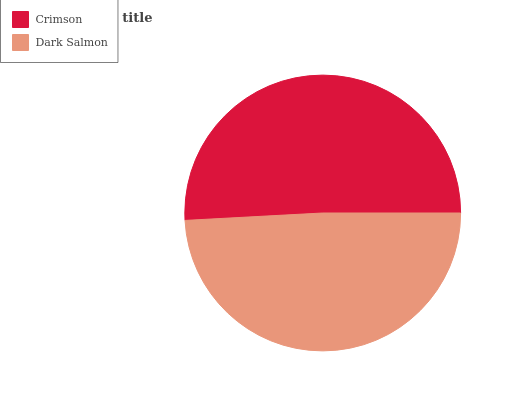Is Dark Salmon the minimum?
Answer yes or no. Yes. Is Crimson the maximum?
Answer yes or no. Yes. Is Dark Salmon the maximum?
Answer yes or no. No. Is Crimson greater than Dark Salmon?
Answer yes or no. Yes. Is Dark Salmon less than Crimson?
Answer yes or no. Yes. Is Dark Salmon greater than Crimson?
Answer yes or no. No. Is Crimson less than Dark Salmon?
Answer yes or no. No. Is Crimson the high median?
Answer yes or no. Yes. Is Dark Salmon the low median?
Answer yes or no. Yes. Is Dark Salmon the high median?
Answer yes or no. No. Is Crimson the low median?
Answer yes or no. No. 